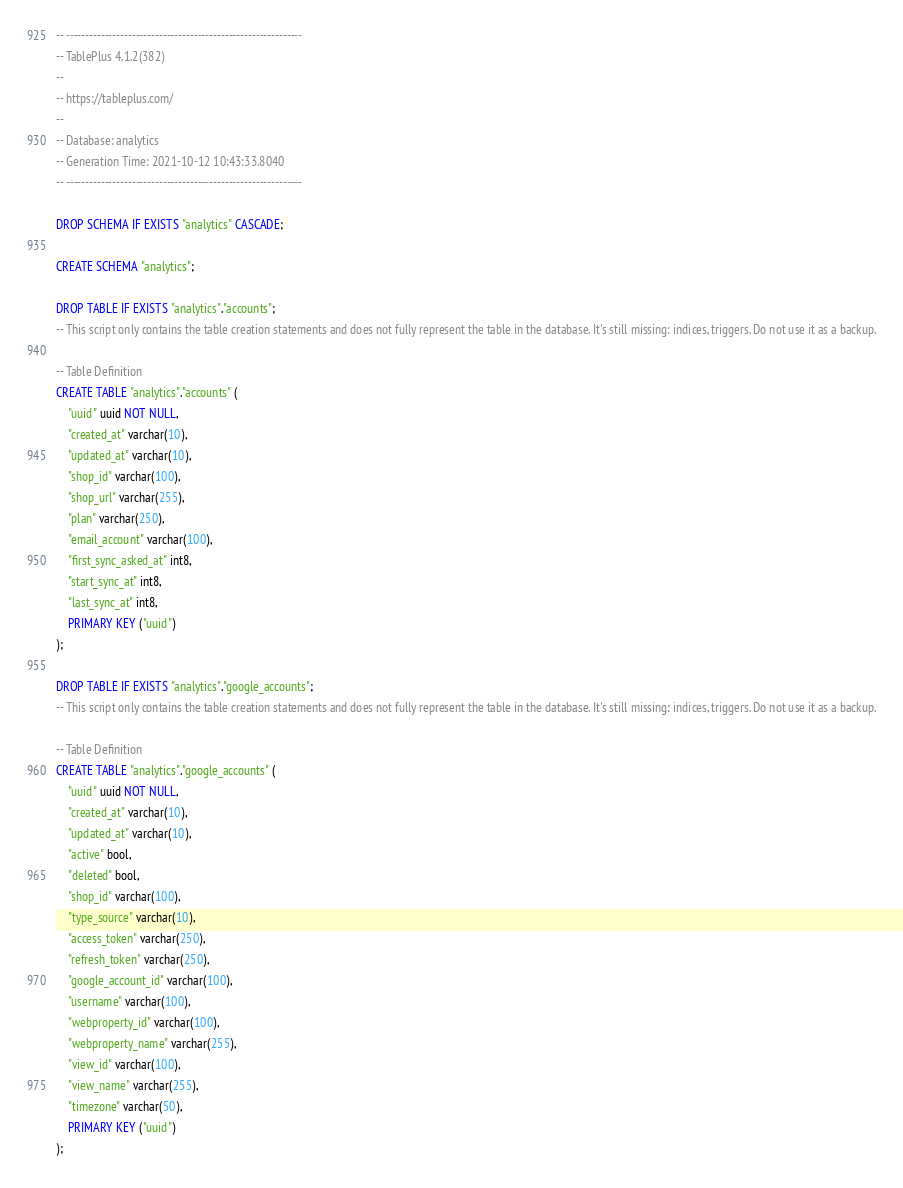Convert code to text. <code><loc_0><loc_0><loc_500><loc_500><_SQL_>-- -------------------------------------------------------------
-- TablePlus 4.1.2(382)
--
-- https://tableplus.com/
--
-- Database: analytics
-- Generation Time: 2021-10-12 10:43:33.8040
-- -------------------------------------------------------------

DROP SCHEMA IF EXISTS "analytics" CASCADE;

CREATE SCHEMA "analytics";

DROP TABLE IF EXISTS "analytics"."accounts";
-- This script only contains the table creation statements and does not fully represent the table in the database. It's still missing: indices, triggers. Do not use it as a backup.

-- Table Definition
CREATE TABLE "analytics"."accounts" (
    "uuid" uuid NOT NULL,
    "created_at" varchar(10),
    "updated_at" varchar(10),
    "shop_id" varchar(100),
    "shop_url" varchar(255),
    "plan" varchar(250),
    "email_account" varchar(100),
    "first_sync_asked_at" int8,
    "start_sync_at" int8,
    "last_sync_at" int8,
    PRIMARY KEY ("uuid")
);

DROP TABLE IF EXISTS "analytics"."google_accounts";
-- This script only contains the table creation statements and does not fully represent the table in the database. It's still missing: indices, triggers. Do not use it as a backup.

-- Table Definition
CREATE TABLE "analytics"."google_accounts" (
    "uuid" uuid NOT NULL,
    "created_at" varchar(10),
    "updated_at" varchar(10),
    "active" bool,
    "deleted" bool,
    "shop_id" varchar(100),
    "type_source" varchar(10),
    "access_token" varchar(250),
    "refresh_token" varchar(250),
    "google_account_id" varchar(100),
    "username" varchar(100),
    "webproperty_id" varchar(100),
    "webproperty_name" varchar(255),
    "view_id" varchar(100),
    "view_name" varchar(255),
    "timezone" varchar(50),
    PRIMARY KEY ("uuid")
);
</code> 